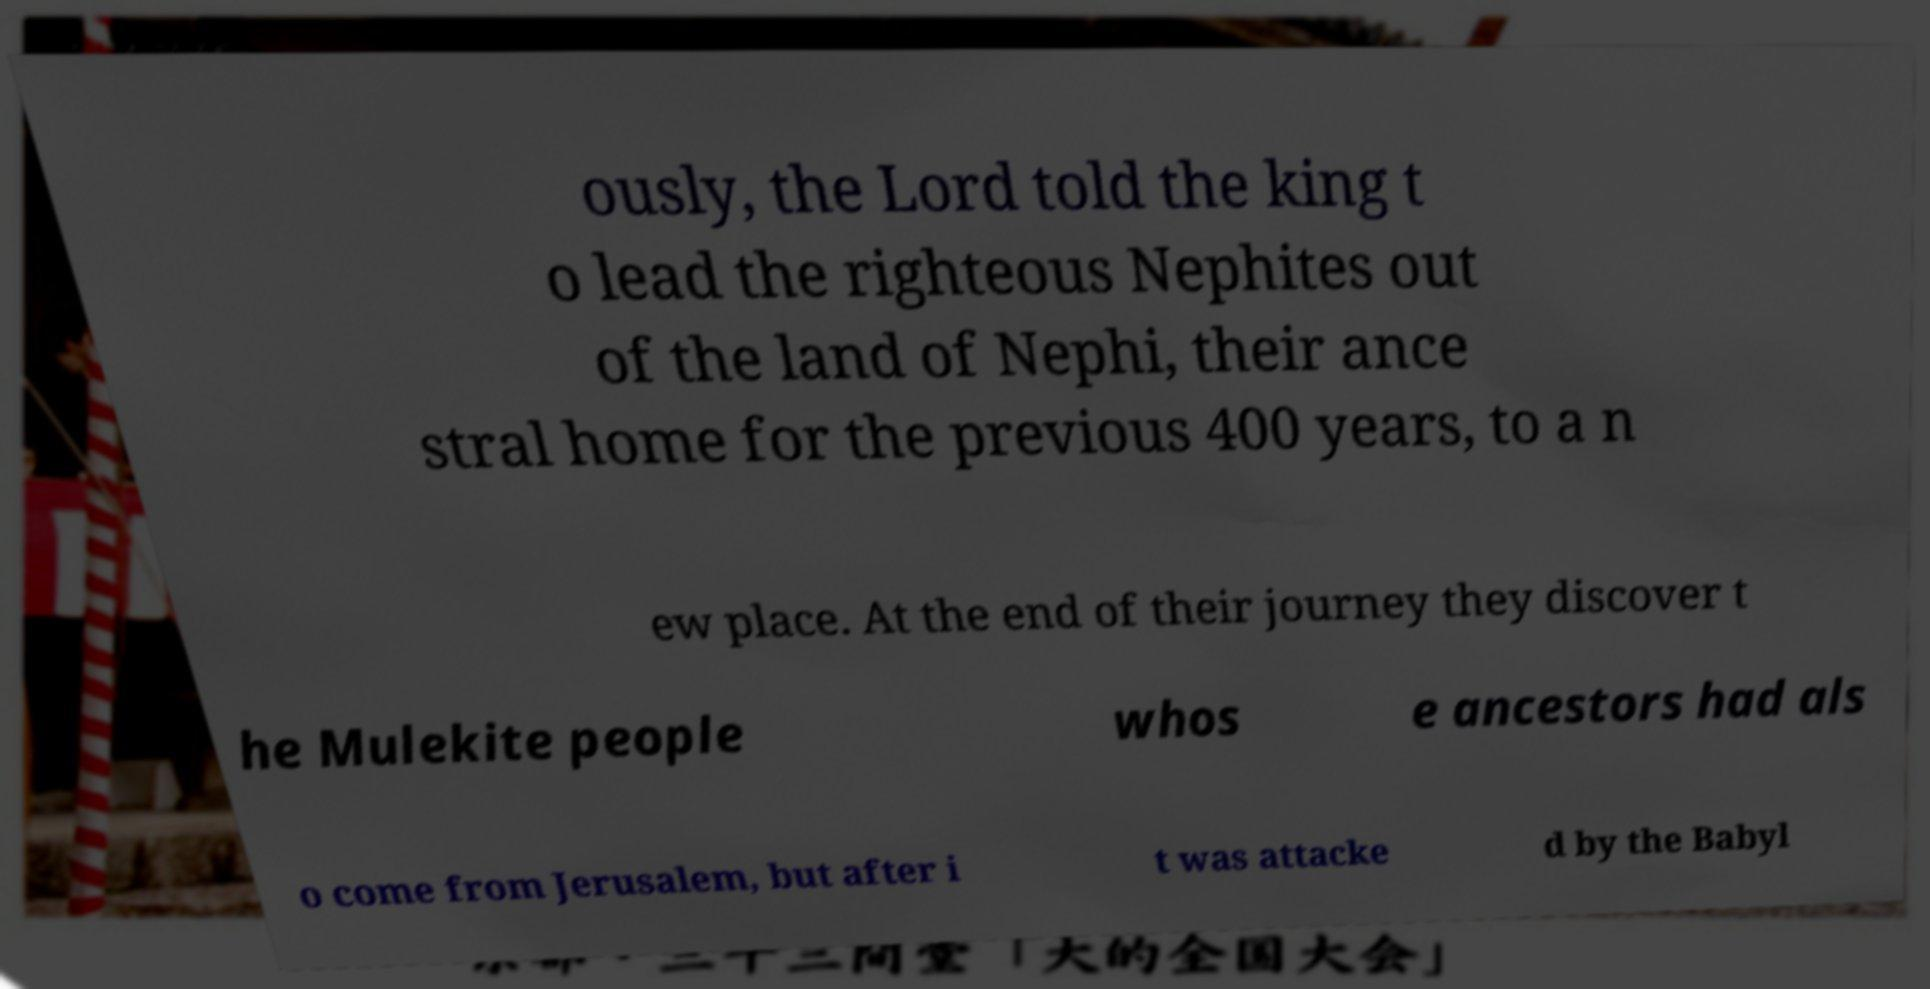What messages or text are displayed in this image? I need them in a readable, typed format. ously, the Lord told the king t o lead the righteous Nephites out of the land of Nephi, their ance stral home for the previous 400 years, to a n ew place. At the end of their journey they discover t he Mulekite people whos e ancestors had als o come from Jerusalem, but after i t was attacke d by the Babyl 